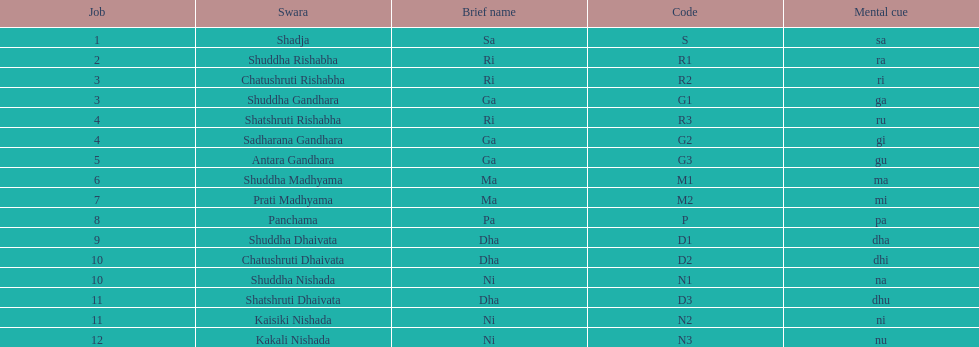What is the name of the swara that comes after panchama? Shuddha Dhaivata. 